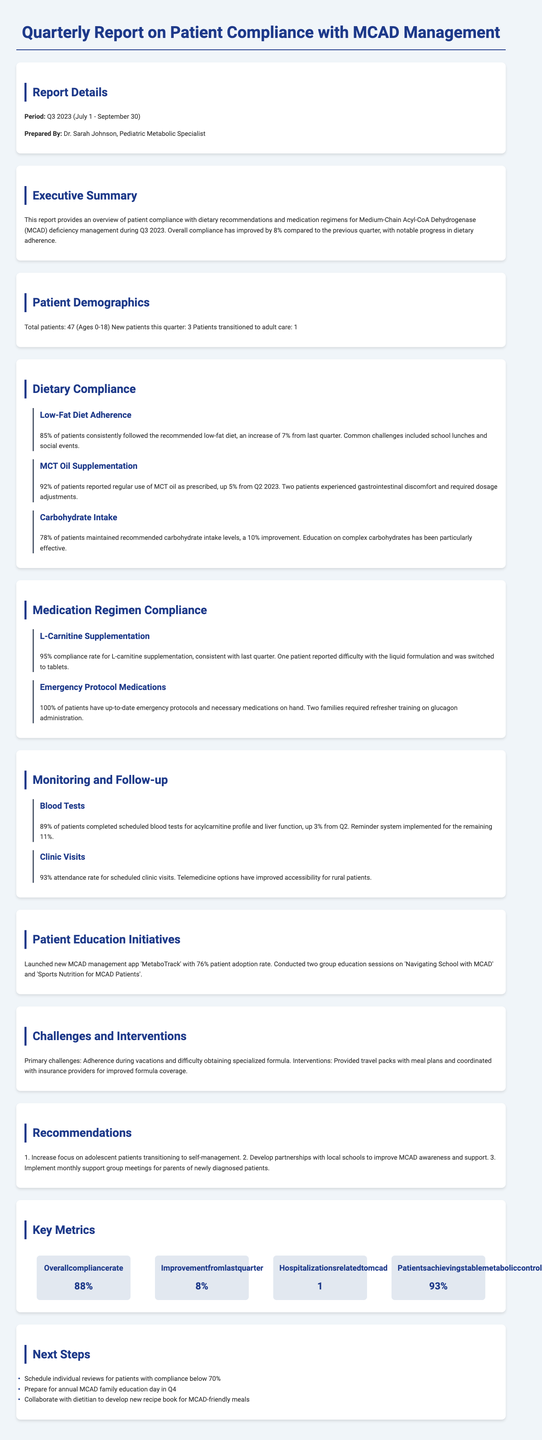what is the overall compliance rate? The overall compliance rate is provided in the key metrics section of the report.
Answer: 88% who prepared the report? The report is prepared by a specific individual mentioned in the report details section.
Answer: Dr. Sarah Johnson, Pediatric Metabolic Specialist how many patients reported regular use of MCT oil? This information can be found in the dietary compliance section regarding MCT oil supplementation.
Answer: 92% what was the improvement in dietary compliance for carbohydrate intake? The report section on carbohydrate intake indicates the percentage of improvement from the last quarter.
Answer: 10% how many patients have completed scheduled blood tests? The monitoring and follow-up section specifies the percentage of patients who completed blood tests.
Answer: 89% what new patient education initiative was launched? The patient education initiatives section describes a specific new initiative for managing MCAD.
Answer: MetaboTrack app how many patients are transitioning to adult care? This information is captured in the patient demographics section of the report.
Answer: 1 what percentage of patients attended scheduled clinic visits? This statistic is included in the monitoring and follow-up section related to clinic visits.
Answer: 93% what is the recommendation regarding adolescents? Recommendations are listed at the end of the report, specifically focused on adolescents.
Answer: Increase focus on adolescent patients transitioning to self-management 